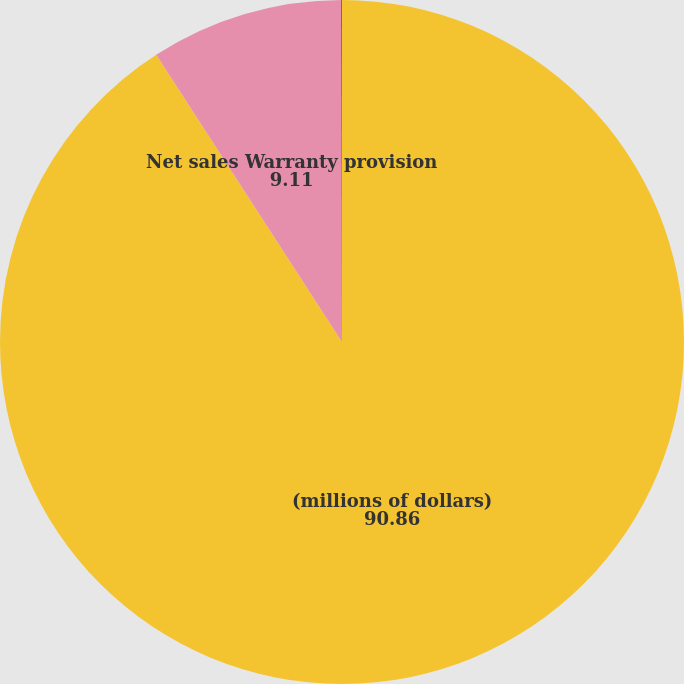Convert chart. <chart><loc_0><loc_0><loc_500><loc_500><pie_chart><fcel>(millions of dollars)<fcel>Net sales Warranty provision<fcel>Warranty provision as a<nl><fcel>90.86%<fcel>9.11%<fcel>0.03%<nl></chart> 